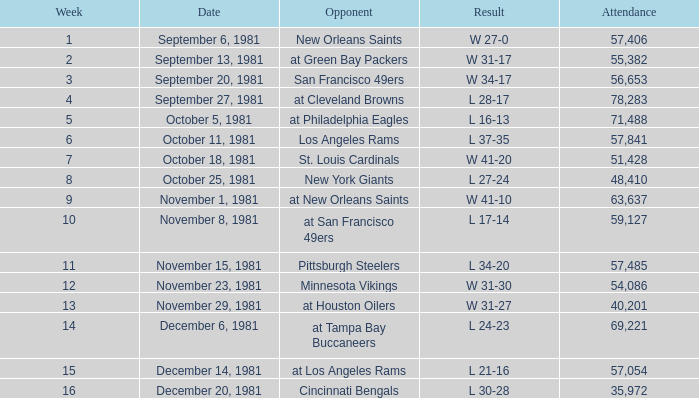What was the mean attendance figure for the game played following the 13th week on november 29, 1981? None. 